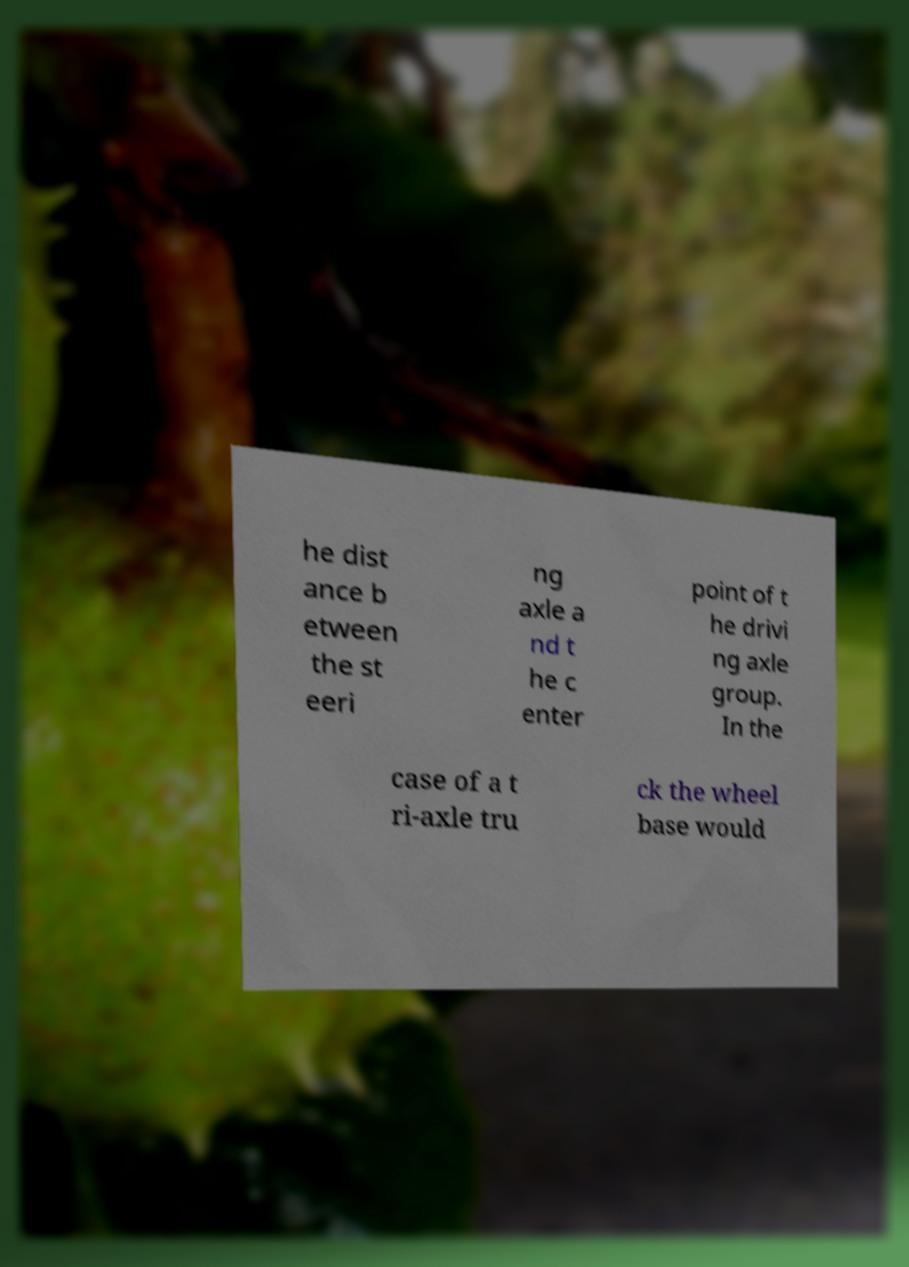I need the written content from this picture converted into text. Can you do that? he dist ance b etween the st eeri ng axle a nd t he c enter point of t he drivi ng axle group. In the case of a t ri-axle tru ck the wheel base would 